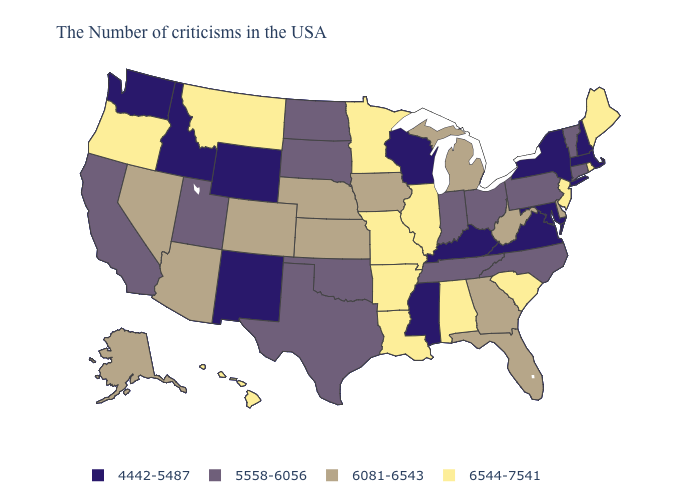What is the highest value in the MidWest ?
Be succinct. 6544-7541. Does New York have the same value as New Hampshire?
Give a very brief answer. Yes. Does Utah have the lowest value in the West?
Quick response, please. No. What is the value of Oregon?
Answer briefly. 6544-7541. Does New York have the highest value in the USA?
Concise answer only. No. Which states have the highest value in the USA?
Give a very brief answer. Maine, Rhode Island, New Jersey, South Carolina, Alabama, Illinois, Louisiana, Missouri, Arkansas, Minnesota, Montana, Oregon, Hawaii. Among the states that border Kansas , which have the lowest value?
Answer briefly. Oklahoma. Which states have the lowest value in the West?
Answer briefly. Wyoming, New Mexico, Idaho, Washington. What is the highest value in the USA?
Quick response, please. 6544-7541. Does the first symbol in the legend represent the smallest category?
Short answer required. Yes. What is the lowest value in states that border Montana?
Give a very brief answer. 4442-5487. What is the lowest value in states that border Iowa?
Keep it brief. 4442-5487. What is the lowest value in states that border Missouri?
Short answer required. 4442-5487. Does the map have missing data?
Be succinct. No. Name the states that have a value in the range 6544-7541?
Write a very short answer. Maine, Rhode Island, New Jersey, South Carolina, Alabama, Illinois, Louisiana, Missouri, Arkansas, Minnesota, Montana, Oregon, Hawaii. 